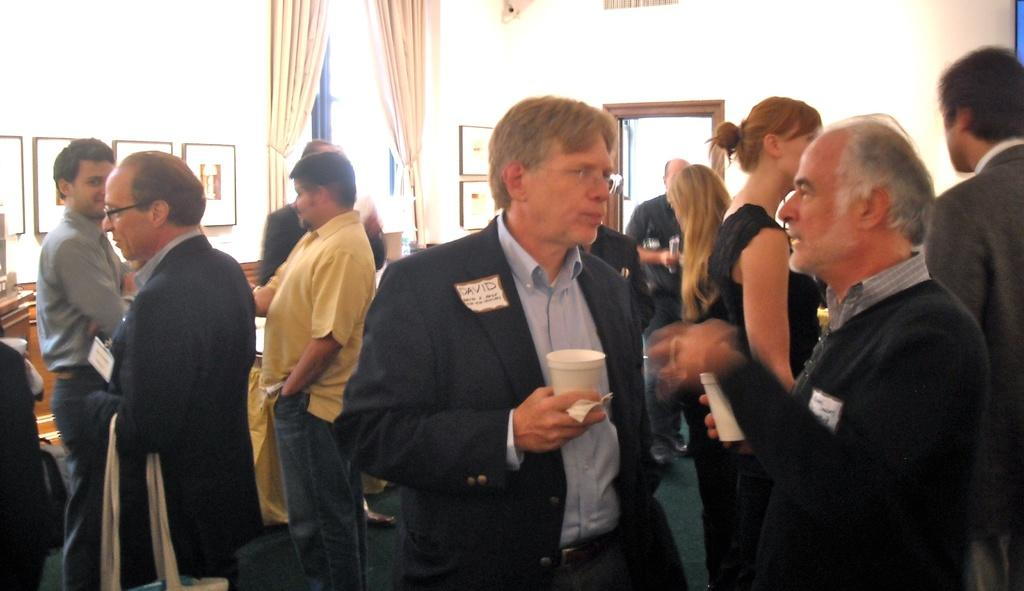What are the people in the image doing? The people in the image are standing. What objects are some people holding in the image? Some people are holding glasses in the image. What can be seen in the background of the image? There is a door and a curtain in the background of the image. What is placed on the wall in the image? Frames are placed on the wall in the image. Reasoning: Let's think step by step by breaking down the facts into individual elements. We start by identifying the main subject, which is the people standing in the image. Then, we describe what they are doing and what objects they are holding. Next, we focus on the background elements, such as the door and curtain. Finally, we mention the frames placed on the wall. Each question is designed to elicit a specific detail about the image that is known from the provided facts. Absurd Question/Answer: What type of rice is being served at the business meeting in the image? There is no business meeting or rice present in the image. The image only shows people standing, holding glasses, and the background elements mentioned earlier. 